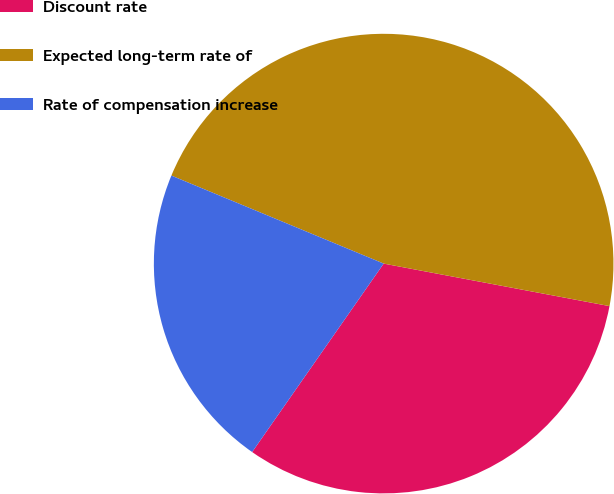Convert chart to OTSL. <chart><loc_0><loc_0><loc_500><loc_500><pie_chart><fcel>Discount rate<fcel>Expected long-term rate of<fcel>Rate of compensation increase<nl><fcel>31.74%<fcel>46.71%<fcel>21.56%<nl></chart> 